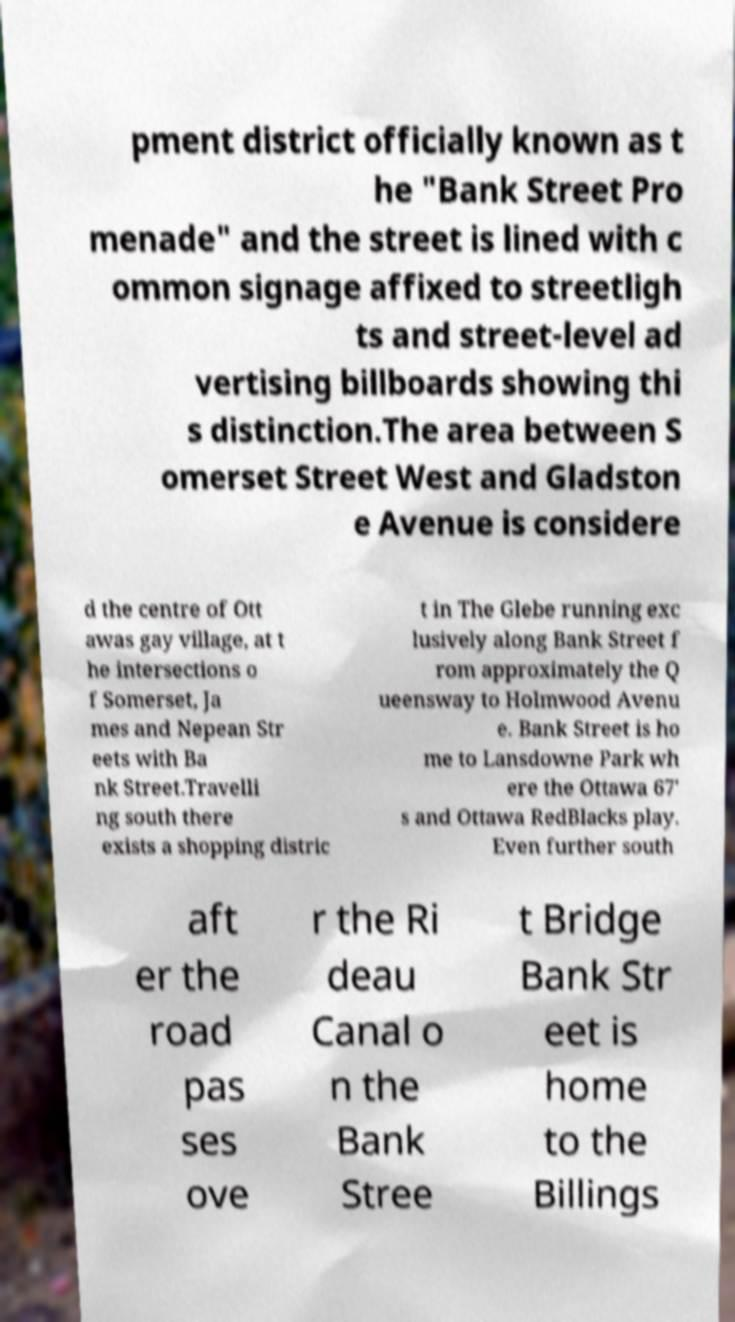Please identify and transcribe the text found in this image. pment district officially known as t he "Bank Street Pro menade" and the street is lined with c ommon signage affixed to streetligh ts and street-level ad vertising billboards showing thi s distinction.The area between S omerset Street West and Gladston e Avenue is considere d the centre of Ott awas gay village, at t he intersections o f Somerset, Ja mes and Nepean Str eets with Ba nk Street.Travelli ng south there exists a shopping distric t in The Glebe running exc lusively along Bank Street f rom approximately the Q ueensway to Holmwood Avenu e. Bank Street is ho me to Lansdowne Park wh ere the Ottawa 67' s and Ottawa RedBlacks play. Even further south aft er the road pas ses ove r the Ri deau Canal o n the Bank Stree t Bridge Bank Str eet is home to the Billings 